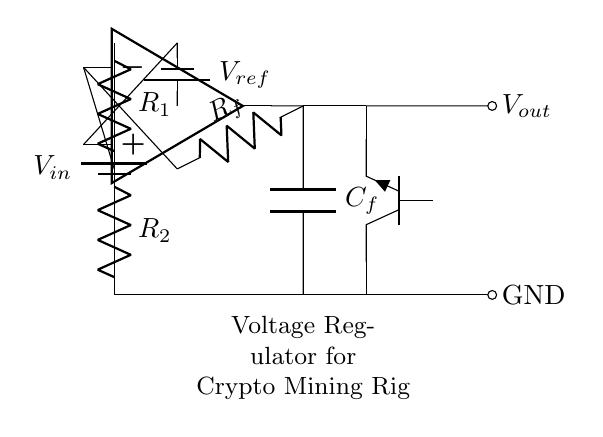What is the input voltage in this circuit? The input voltage is represented by the voltage source labeled V_in at the top left of the circuit diagram.
Answer: V_in What type of transistor is used in this circuit? The circuit includes a pass transistor indicated as Tnpn, which shows that it is a type of bipolar junction transistor (BJT) specifically an NPN transistor.
Answer: NPN What are the two resistors in the voltage divider? The voltage divider consists of two resistors labeled R_1 and R_2, which are connected in series between the input voltage and ground.
Answer: R_1 and R_2 What is the role of the op-amp in this circuit? The op-amp functions as an error amplifier, comparing the output voltage to the reference voltage V_ref and adjusting the transistor accordingly to regulate V_out.
Answer: Error amplifier What is the output voltage represented as? The output voltage is shown as V_out, which is the voltage across the load after regulation by the circuit.
Answer: V_out What component is placed to maintain feedback in the circuit? The component used to maintain feedback is labeled as C_f, indicating a capacitor that is connected between the output of the op-amp and ground, helping stabilize the output voltage.
Answer: C_f Which component provides the reference voltage? The reference voltage is provided by the voltage source labeled V_ref connected to the non-inverting input of the op-amp.
Answer: V_ref 